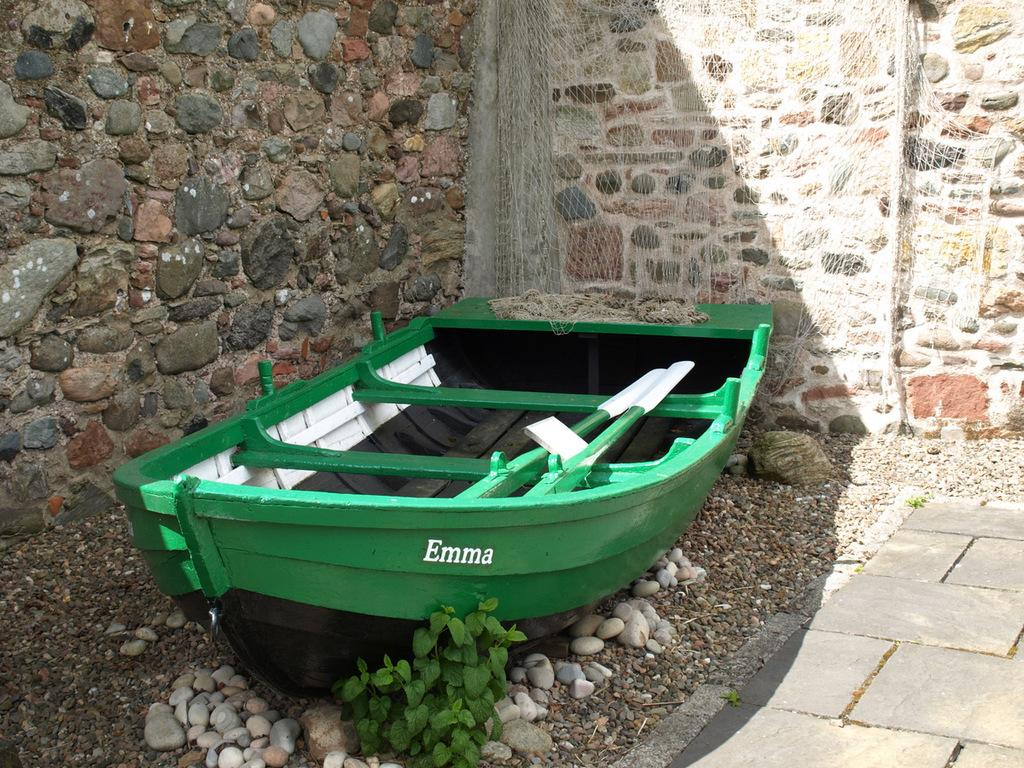What is the main subject of the image? The main subject of the image is a boat. Can you describe the boat's appearance? The boat is green in color. What can be seen at the bottom of the image? There are stones and tiles at the bottom of the image. What other objects are present in the image? There is a wall and a net in the image. What advice does the boat give to the stones in the image? There is no dialogue or interaction between the boat and the stones in the image, so it is not possible to determine any advice given. 